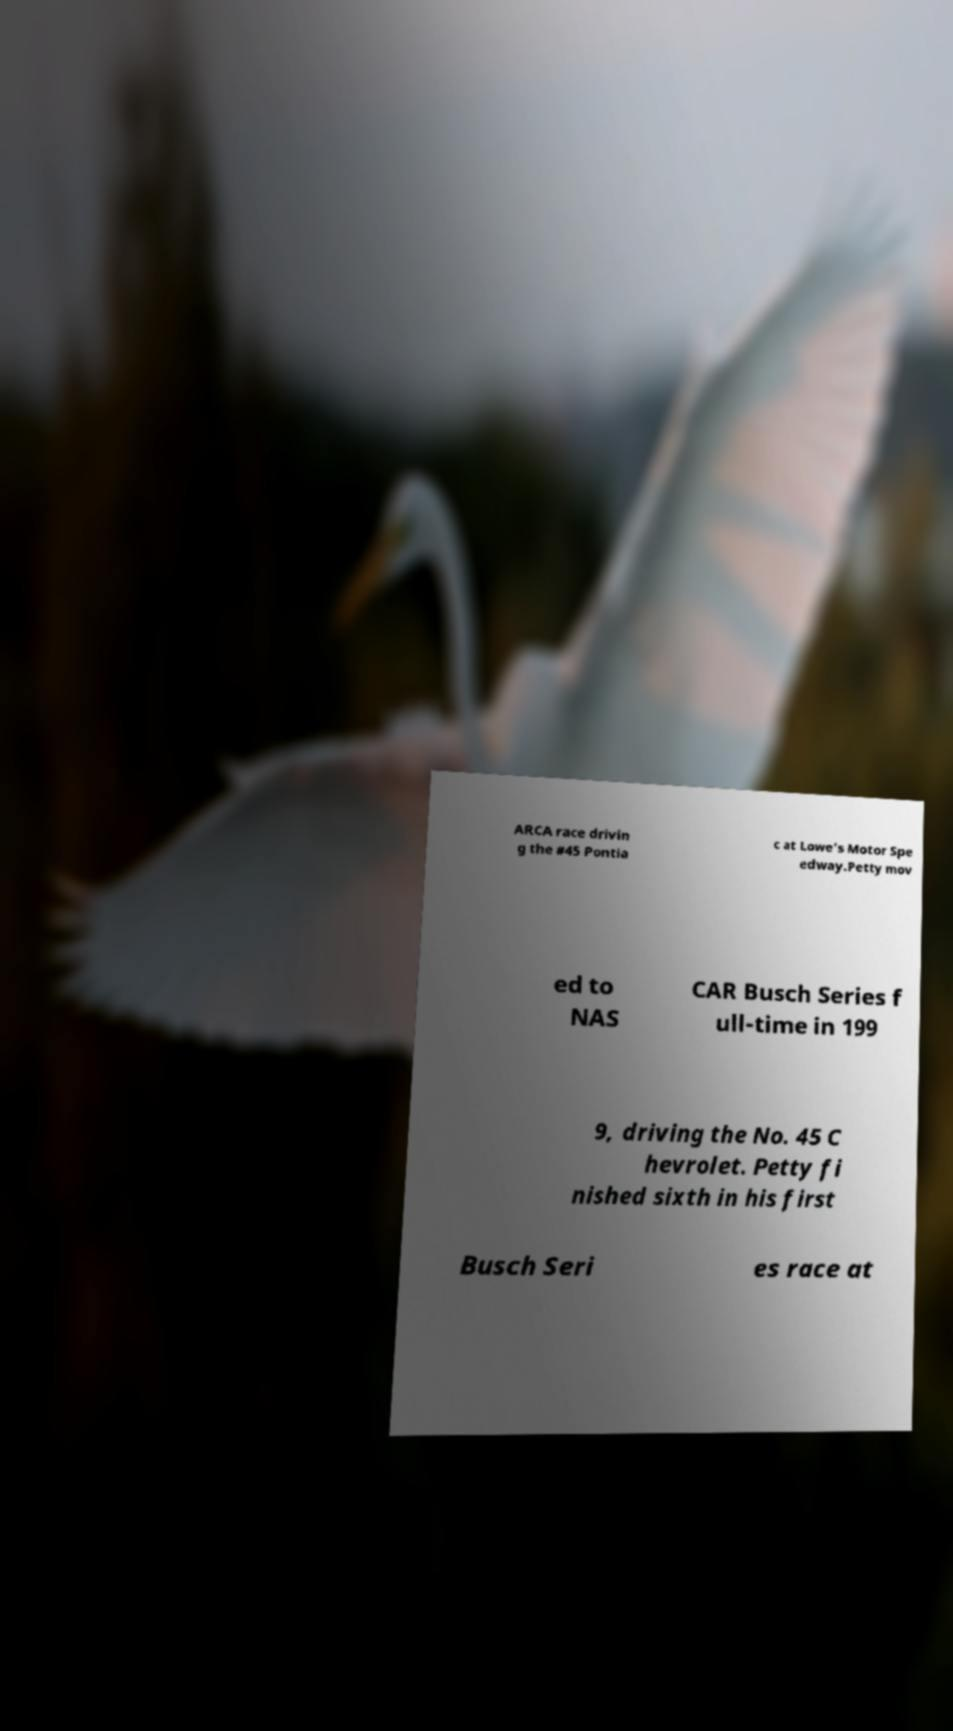Please identify and transcribe the text found in this image. ARCA race drivin g the #45 Pontia c at Lowe's Motor Spe edway.Petty mov ed to NAS CAR Busch Series f ull-time in 199 9, driving the No. 45 C hevrolet. Petty fi nished sixth in his first Busch Seri es race at 